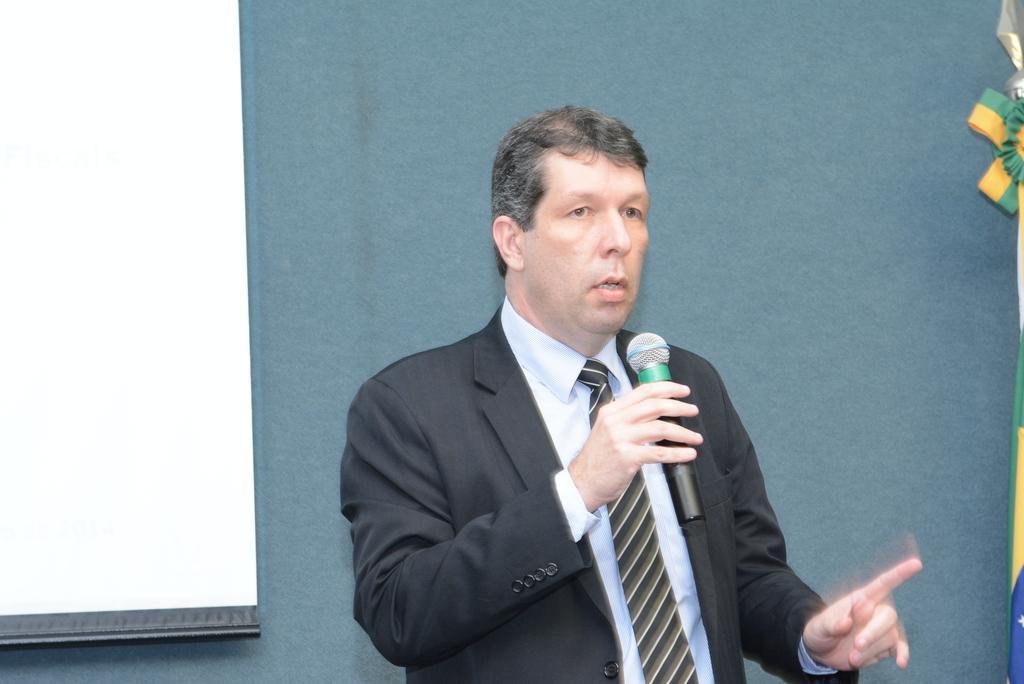In one or two sentences, can you explain what this image depicts? In this picture we can see man wore blazer, tie and holding mic in his hand and talking and in background we can see wall, screen. 